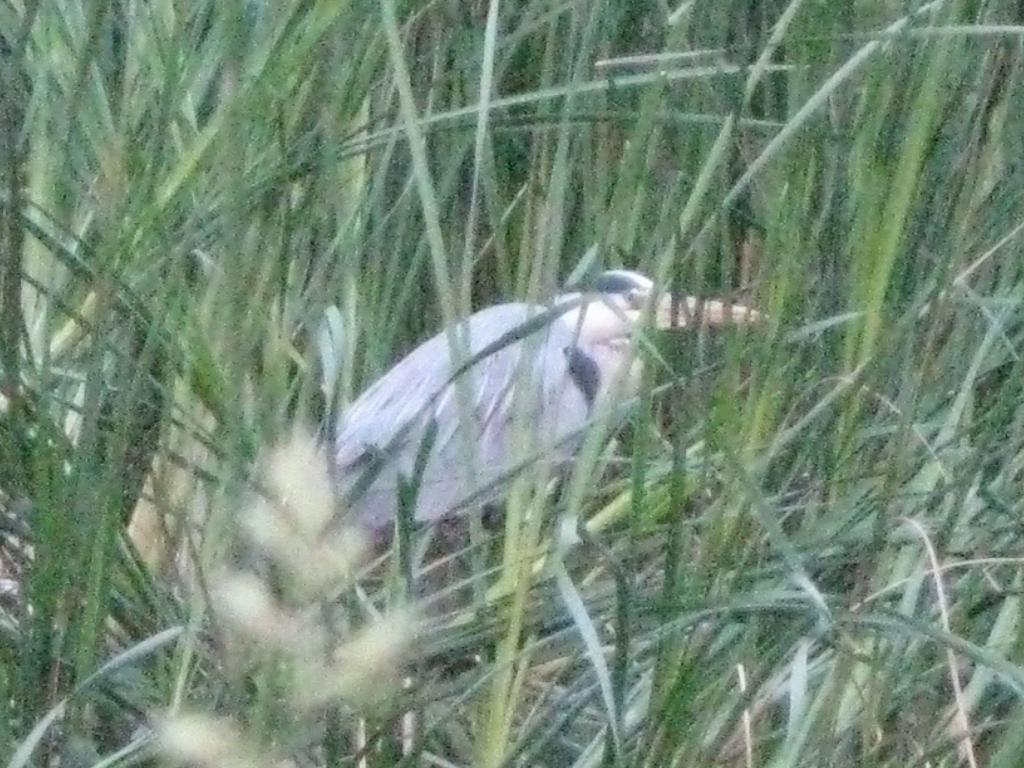In one or two sentences, can you explain what this image depicts? This image is taken outdoors. In the middle of the image there is a bird. In this image there is grass. 